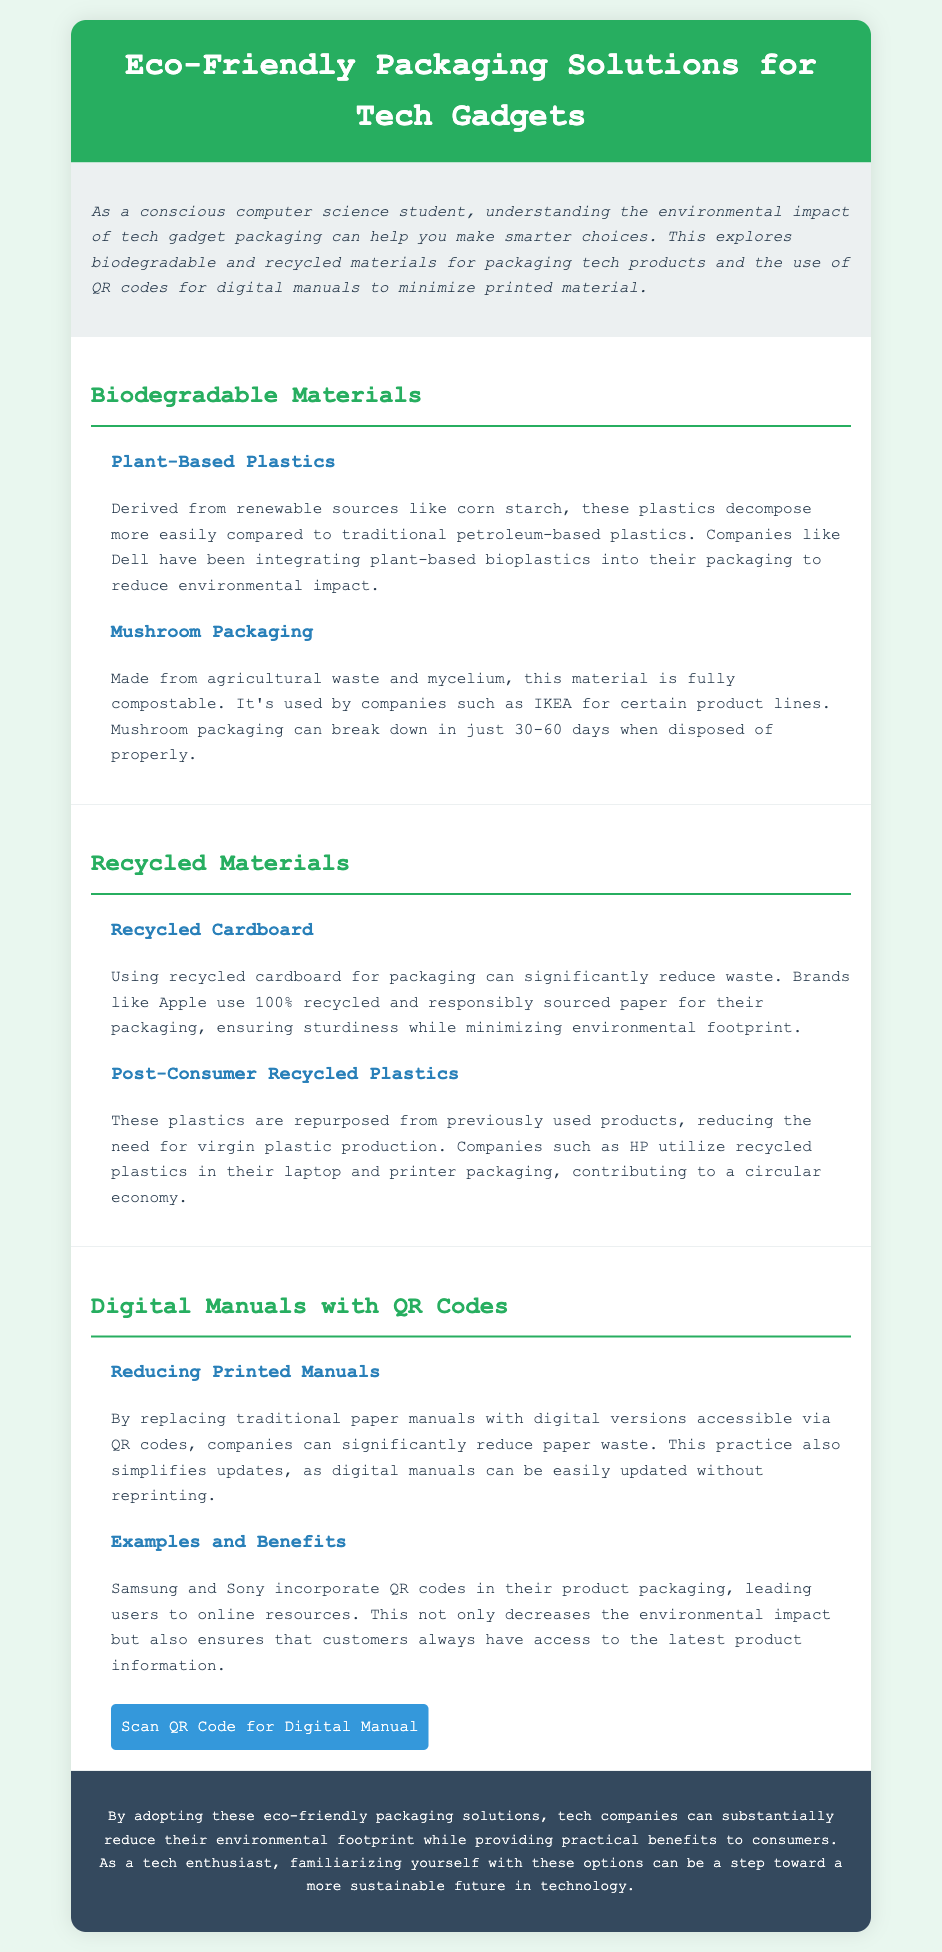what is the title of the document? The title is prominently displayed in the header section of the document.
Answer: Eco-Friendly Packaging Solutions for Tech Gadgets who uses plant-based bioplastics in their packaging? The document mentions a specific company that integrates plant-based bioplastics into their packaging.
Answer: Dell how long does mushroom packaging take to decompose? This information is provided in the section on mushroom packaging, specifying the decomposition period.
Answer: 30-60 days which material significantly reduces waste when used in packaging? The document discusses one specific material that is highlighted for its waste reduction capabilities.
Answer: Recycled cardboard what do QR codes replace in product packaging? The document explains the role of QR codes in relation to traditional materials.
Answer: Printed manuals which companies incorporate QR codes in their product packaging? The document cites companies that utilize QR codes for accessibility to product information.
Answer: Samsung and Sony what type of plastics do companies like HP use? The document specifies the category of plastics used by HP to support sustainability.
Answer: Post-Consumer Recycled Plastics what benefit arises from using digital manuals with QR codes? The document discusses advantages related to the implementation of QR codes for manuals.
Answer: Reducing paper waste 